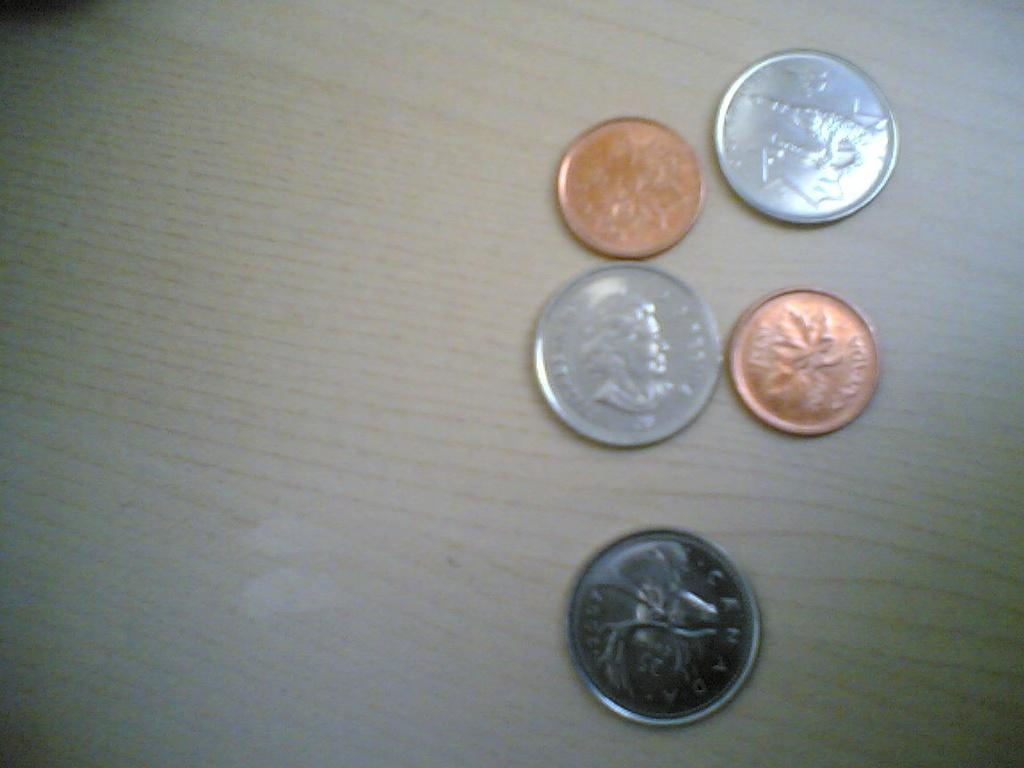<image>
Present a compact description of the photo's key features. Five coins from Canada have been left on the table. 